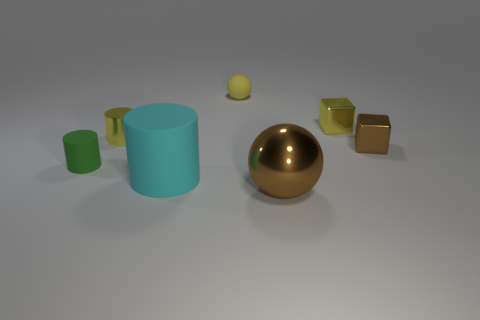There is a green matte cylinder; does it have the same size as the brown shiny object that is in front of the tiny brown cube?
Give a very brief answer. No. How many big matte things have the same color as the small shiny cylinder?
Your answer should be compact. 0. What number of objects are big blue matte cylinders or things that are behind the cyan cylinder?
Ensure brevity in your answer.  5. There is a brown metallic thing in front of the green thing; is its size the same as the brown object behind the green cylinder?
Ensure brevity in your answer.  No. Is there a tiny block that has the same material as the big brown thing?
Offer a very short reply. Yes. What is the shape of the cyan object?
Ensure brevity in your answer.  Cylinder. What shape is the tiny green object that is in front of the brown object that is behind the tiny green rubber cylinder?
Provide a short and direct response. Cylinder. How many other objects are the same shape as the big brown metallic thing?
Your response must be concise. 1. There is a metallic object behind the small cylinder behind the tiny brown thing; what is its size?
Your answer should be very brief. Small. Are there any small yellow metallic objects?
Provide a short and direct response. Yes. 